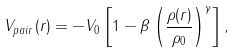Convert formula to latex. <formula><loc_0><loc_0><loc_500><loc_500>V _ { p a i r } ( { r } ) = - V _ { 0 } \left [ 1 - \beta \left ( \frac { \rho ( { r } ) } { \rho _ { 0 } } \right ) ^ { \gamma } \right ] ,</formula> 